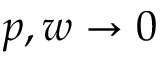Convert formula to latex. <formula><loc_0><loc_0><loc_500><loc_500>p , w \rightarrow 0</formula> 